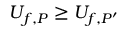Convert formula to latex. <formula><loc_0><loc_0><loc_500><loc_500>U _ { f , P } \geq U _ { f , P ^ { \prime } } \,</formula> 